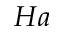<formula> <loc_0><loc_0><loc_500><loc_500>H a</formula> 